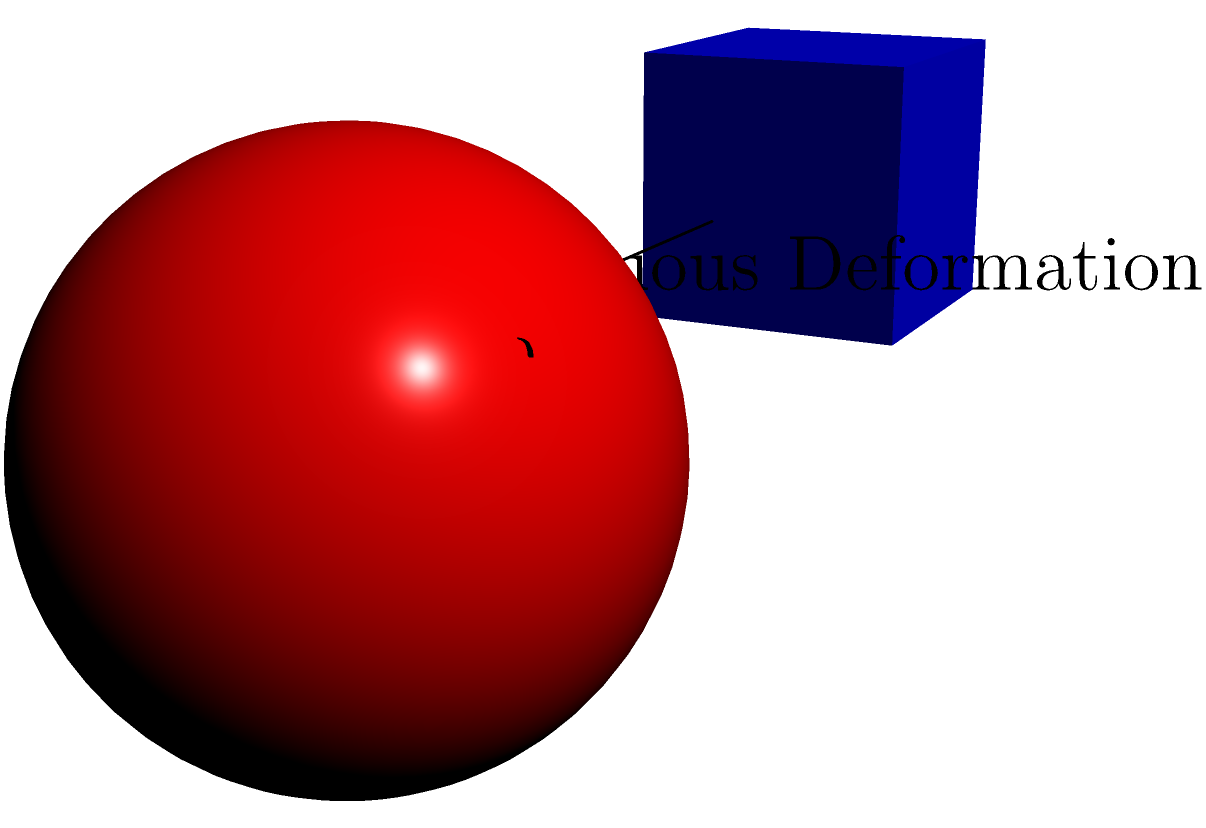In the context of topology, consider the transformation of a cube into a sphere through continuous deformation, as shown in the figure. Which of the following properties is preserved during this transformation?

A) Number of vertices
B) Number of edges
C) Surface area
D) Euler characteristic

How might you use this concept to explain topological equivalence to a child undergoing medical treatment? To answer this question, let's consider each option step-by-step:

1) Number of vertices:
   - A cube has 8 vertices
   - A sphere has no distinct vertices
   - Therefore, the number of vertices is not preserved

2) Number of edges:
   - A cube has 12 edges
   - A sphere has no distinct edges
   - Therefore, the number of edges is not preserved

3) Surface area:
   - The surface area of a cube is $6a^2$, where $a$ is the length of an edge
   - The surface area of a sphere is $4\pi r^2$, where $r$ is the radius
   - These are generally not equal, so surface area is not preserved

4) Euler characteristic:
   - For a cube: $V - E + F = 8 - 12 + 6 = 2$
   - For a sphere: $V - E + F = 2$ (consider it as a single face)
   - The Euler characteristic remains 2 for both shapes

Therefore, the Euler characteristic is preserved during this transformation.

To explain this to a child undergoing treatment, you could use a balloon analogy:
Imagine the cube is like a deflated, cube-shaped balloon. As you blow air into it, it gradually becomes more rounded until it's a sphere. Throughout this process, you haven't torn or punctured the balloon - it's still one continuous surface. This is what we mean by topological equivalence: shapes that can be transformed into each other without breaking or gluing.
Answer: D) Euler characteristic 